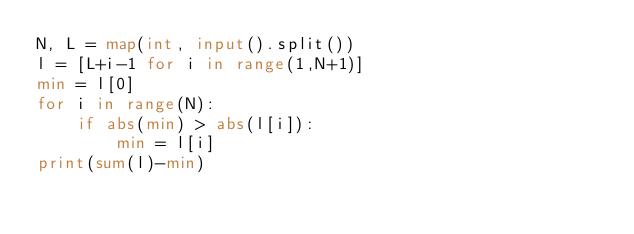Convert code to text. <code><loc_0><loc_0><loc_500><loc_500><_Python_>N, L = map(int, input().split())
l = [L+i-1 for i in range(1,N+1)]
min = l[0]
for i in range(N):
    if abs(min) > abs(l[i]):
        min = l[i]
print(sum(l)-min)</code> 